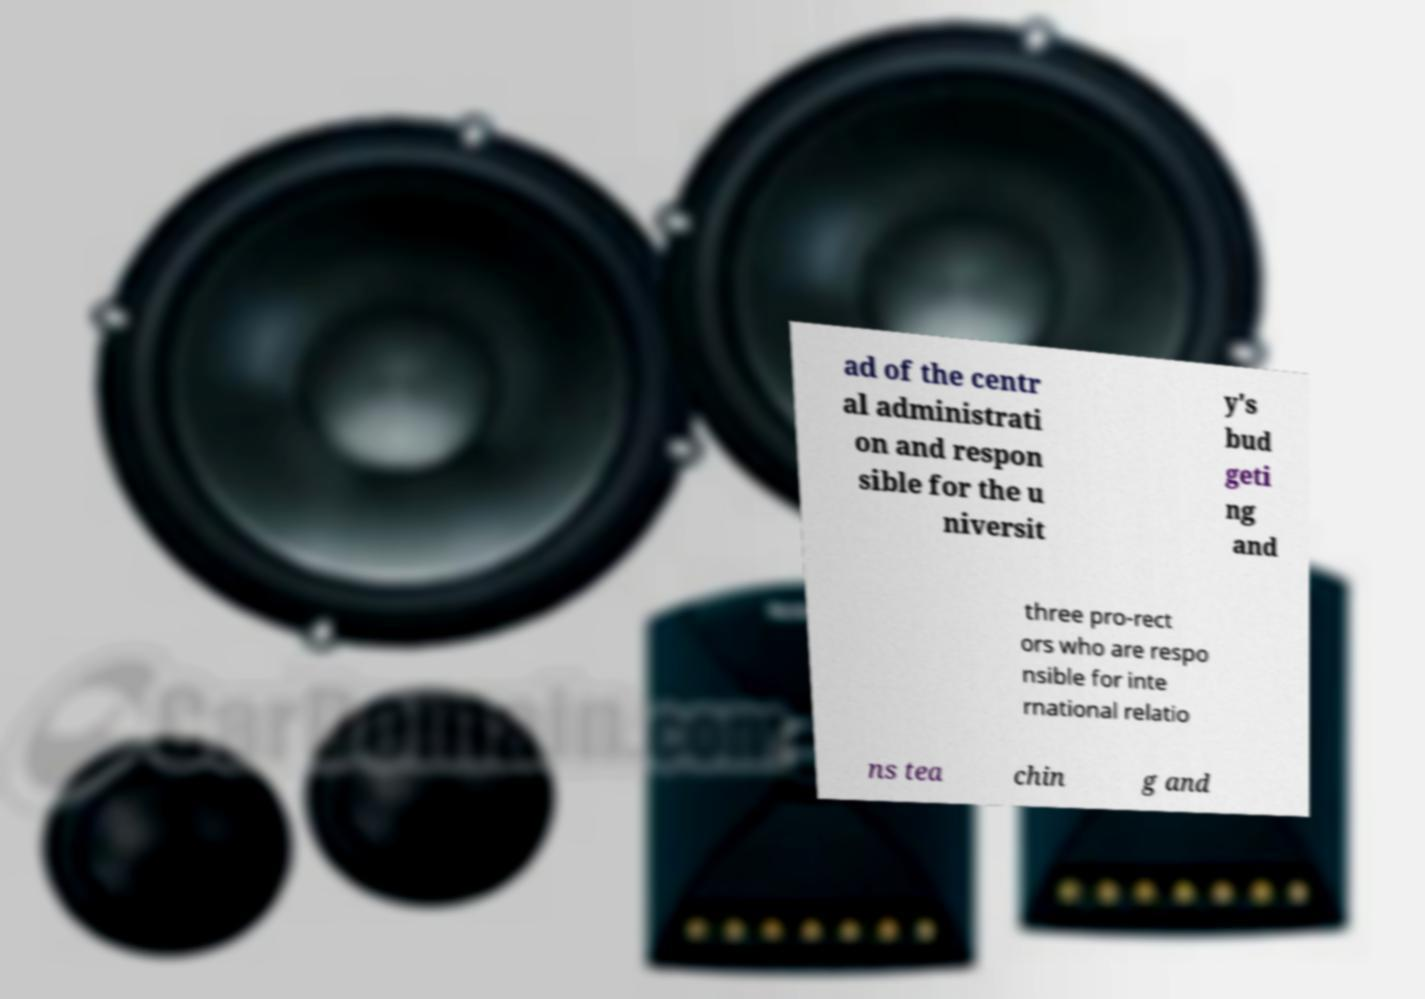There's text embedded in this image that I need extracted. Can you transcribe it verbatim? ad of the centr al administrati on and respon sible for the u niversit y's bud geti ng and three pro-rect ors who are respo nsible for inte rnational relatio ns tea chin g and 